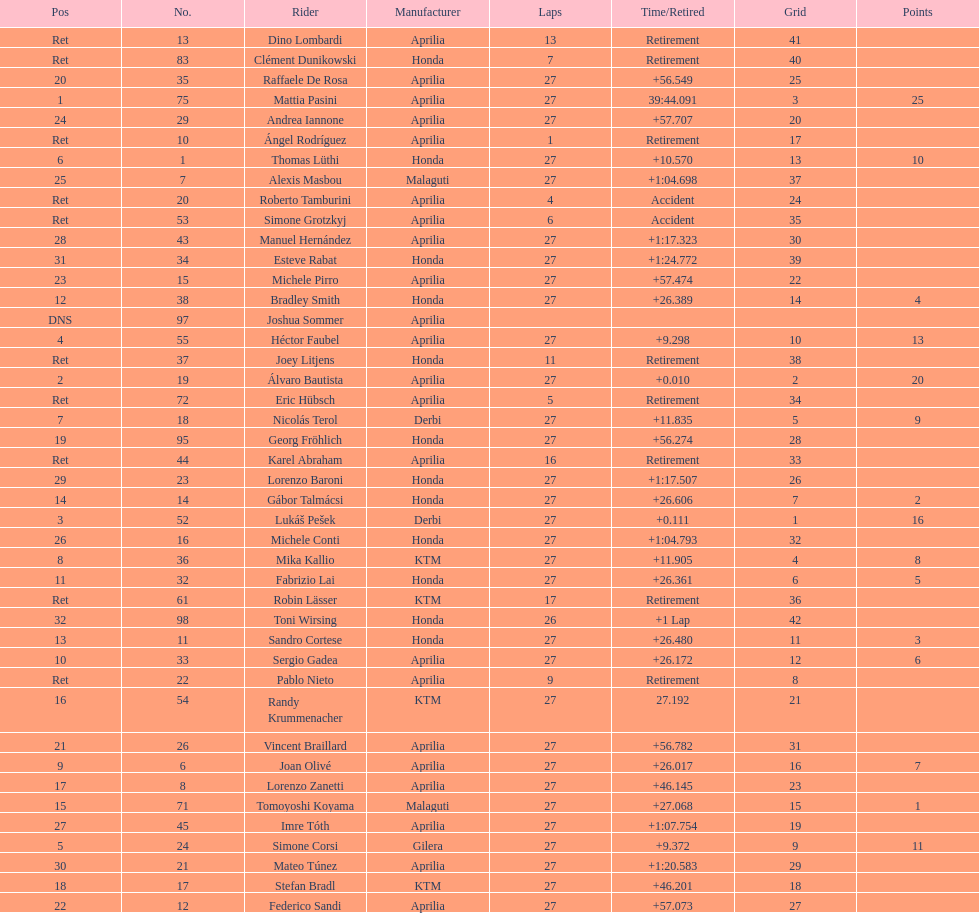Give me the full table as a dictionary. {'header': ['Pos', 'No.', 'Rider', 'Manufacturer', 'Laps', 'Time/Retired', 'Grid', 'Points'], 'rows': [['Ret', '13', 'Dino Lombardi', 'Aprilia', '13', 'Retirement', '41', ''], ['Ret', '83', 'Clément Dunikowski', 'Honda', '7', 'Retirement', '40', ''], ['20', '35', 'Raffaele De Rosa', 'Aprilia', '27', '+56.549', '25', ''], ['1', '75', 'Mattia Pasini', 'Aprilia', '27', '39:44.091', '3', '25'], ['24', '29', 'Andrea Iannone', 'Aprilia', '27', '+57.707', '20', ''], ['Ret', '10', 'Ángel Rodríguez', 'Aprilia', '1', 'Retirement', '17', ''], ['6', '1', 'Thomas Lüthi', 'Honda', '27', '+10.570', '13', '10'], ['25', '7', 'Alexis Masbou', 'Malaguti', '27', '+1:04.698', '37', ''], ['Ret', '20', 'Roberto Tamburini', 'Aprilia', '4', 'Accident', '24', ''], ['Ret', '53', 'Simone Grotzkyj', 'Aprilia', '6', 'Accident', '35', ''], ['28', '43', 'Manuel Hernández', 'Aprilia', '27', '+1:17.323', '30', ''], ['31', '34', 'Esteve Rabat', 'Honda', '27', '+1:24.772', '39', ''], ['23', '15', 'Michele Pirro', 'Aprilia', '27', '+57.474', '22', ''], ['12', '38', 'Bradley Smith', 'Honda', '27', '+26.389', '14', '4'], ['DNS', '97', 'Joshua Sommer', 'Aprilia', '', '', '', ''], ['4', '55', 'Héctor Faubel', 'Aprilia', '27', '+9.298', '10', '13'], ['Ret', '37', 'Joey Litjens', 'Honda', '11', 'Retirement', '38', ''], ['2', '19', 'Álvaro Bautista', 'Aprilia', '27', '+0.010', '2', '20'], ['Ret', '72', 'Eric Hübsch', 'Aprilia', '5', 'Retirement', '34', ''], ['7', '18', 'Nicolás Terol', 'Derbi', '27', '+11.835', '5', '9'], ['19', '95', 'Georg Fröhlich', 'Honda', '27', '+56.274', '28', ''], ['Ret', '44', 'Karel Abraham', 'Aprilia', '16', 'Retirement', '33', ''], ['29', '23', 'Lorenzo Baroni', 'Honda', '27', '+1:17.507', '26', ''], ['14', '14', 'Gábor Talmácsi', 'Honda', '27', '+26.606', '7', '2'], ['3', '52', 'Lukáš Pešek', 'Derbi', '27', '+0.111', '1', '16'], ['26', '16', 'Michele Conti', 'Honda', '27', '+1:04.793', '32', ''], ['8', '36', 'Mika Kallio', 'KTM', '27', '+11.905', '4', '8'], ['11', '32', 'Fabrizio Lai', 'Honda', '27', '+26.361', '6', '5'], ['Ret', '61', 'Robin Lässer', 'KTM', '17', 'Retirement', '36', ''], ['32', '98', 'Toni Wirsing', 'Honda', '26', '+1 Lap', '42', ''], ['13', '11', 'Sandro Cortese', 'Honda', '27', '+26.480', '11', '3'], ['10', '33', 'Sergio Gadea', 'Aprilia', '27', '+26.172', '12', '6'], ['Ret', '22', 'Pablo Nieto', 'Aprilia', '9', 'Retirement', '8', ''], ['16', '54', 'Randy Krummenacher', 'KTM', '27', '27.192', '21', ''], ['21', '26', 'Vincent Braillard', 'Aprilia', '27', '+56.782', '31', ''], ['9', '6', 'Joan Olivé', 'Aprilia', '27', '+26.017', '16', '7'], ['17', '8', 'Lorenzo Zanetti', 'Aprilia', '27', '+46.145', '23', ''], ['15', '71', 'Tomoyoshi Koyama', 'Malaguti', '27', '+27.068', '15', '1'], ['27', '45', 'Imre Tóth', 'Aprilia', '27', '+1:07.754', '19', ''], ['5', '24', 'Simone Corsi', 'Gilera', '27', '+9.372', '9', '11'], ['30', '21', 'Mateo Túnez', 'Aprilia', '27', '+1:20.583', '29', ''], ['18', '17', 'Stefan Bradl', 'KTM', '27', '+46.201', '18', ''], ['22', '12', 'Federico Sandi', 'Aprilia', '27', '+57.073', '27', '']]} Who placed higher, bradl or gadea? Sergio Gadea. 